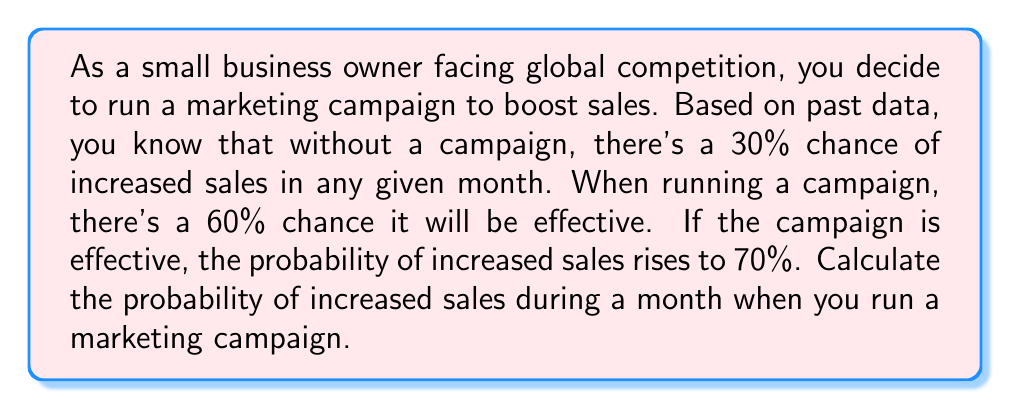Could you help me with this problem? Let's approach this step-by-step using the law of total probability:

1) Define events:
   A: Increased sales
   E: Effective campaign
   
2) Given probabilities:
   $P(A|\text{no campaign}) = 0.30$
   $P(E) = 0.60$ (probability of campaign being effective)
   $P(A|E) = 0.70$ (probability of increased sales if campaign is effective)

3) We need to find $P(A|\text{campaign})$. Let's use the law of total probability:

   $$P(A|\text{campaign}) = P(A|E) \cdot P(E) + P(A|\text{not }E) \cdot P(\text{not }E)$$

4) We know $P(A|E)$ and $P(E)$, but we need $P(A|\text{not }E)$:
   Since the campaign being ineffective is equivalent to not running a campaign:
   $P(A|\text{not }E) = P(A|\text{no campaign}) = 0.30$

5) Calculate $P(\text{not }E)$:
   $P(\text{not }E) = 1 - P(E) = 1 - 0.60 = 0.40$

6) Now we can substitute all values into the formula:

   $$P(A|\text{campaign}) = 0.70 \cdot 0.60 + 0.30 \cdot 0.40$$

7) Calculate:
   $$P(A|\text{campaign}) = 0.42 + 0.12 = 0.54$$

Therefore, the probability of increased sales during a month when you run a marketing campaign is 0.54 or 54%.
Answer: $0.54$ or $54\%$ 